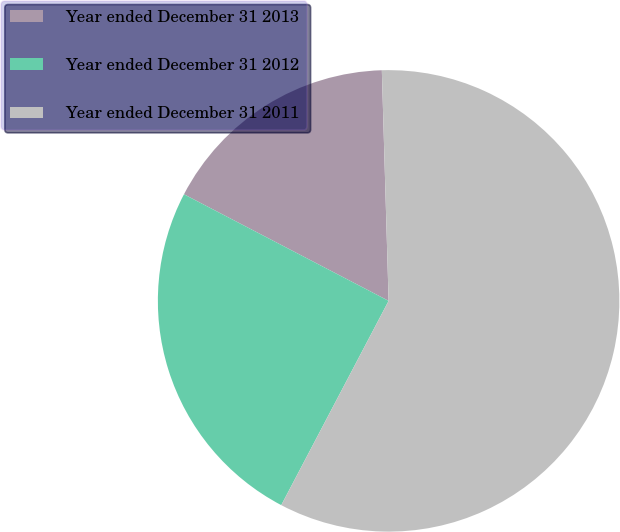Convert chart. <chart><loc_0><loc_0><loc_500><loc_500><pie_chart><fcel>Year ended December 31 2013<fcel>Year ended December 31 2012<fcel>Year ended December 31 2011<nl><fcel>16.89%<fcel>24.94%<fcel>58.17%<nl></chart> 